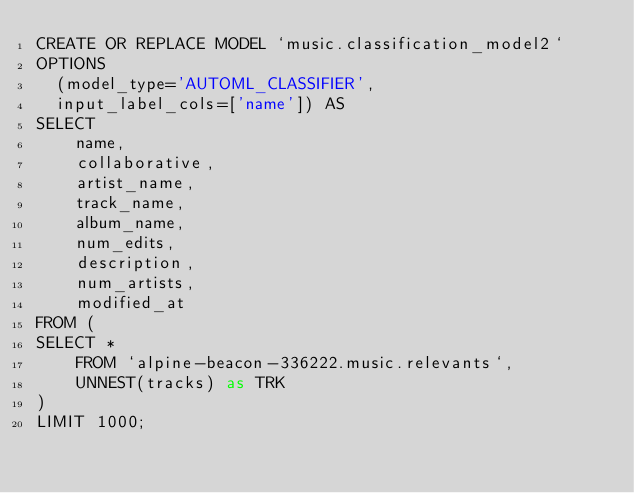<code> <loc_0><loc_0><loc_500><loc_500><_SQL_>CREATE OR REPLACE MODEL `music.classification_model2`
OPTIONS
  (model_type='AUTOML_CLASSIFIER',
  input_label_cols=['name']) AS
SELECT 
    name,
    collaborative,
    artist_name,
    track_name,
    album_name,
    num_edits,
    description,
    num_artists,
    modified_at
FROM (
SELECT *
    FROM `alpine-beacon-336222.music.relevants`,
    UNNEST(tracks) as TRK
)
LIMIT 1000;</code> 